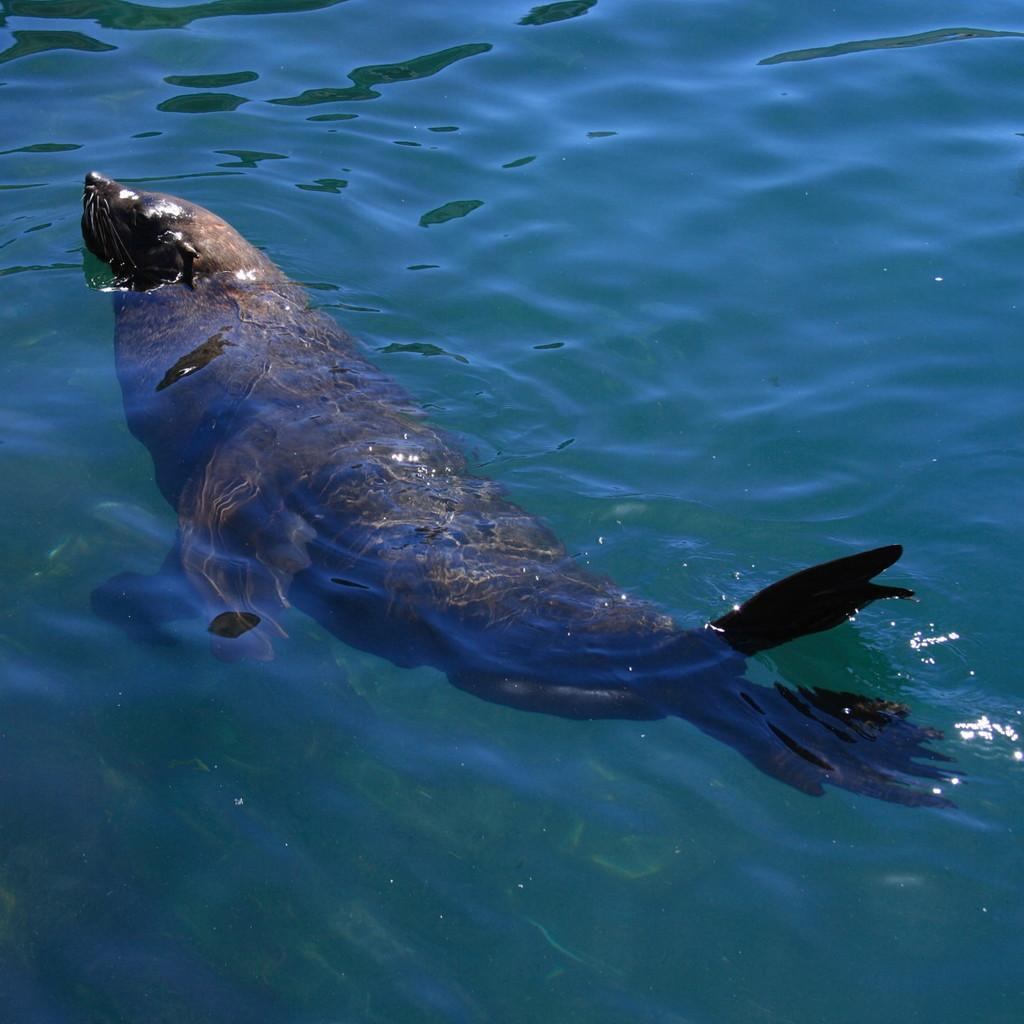What animal is present in the image? There is a seal in the image. Where is the seal located? The seal is in the water. What is the condition of the water in the image? The water is flowing in the image. What type of butter is being used by the beggar in the image? There is no beggar or butter present in the image; it features a seal in the water. What is the relationship between the seal and the sister in the image? There is no sister present in the image; it features a seal in the water. 